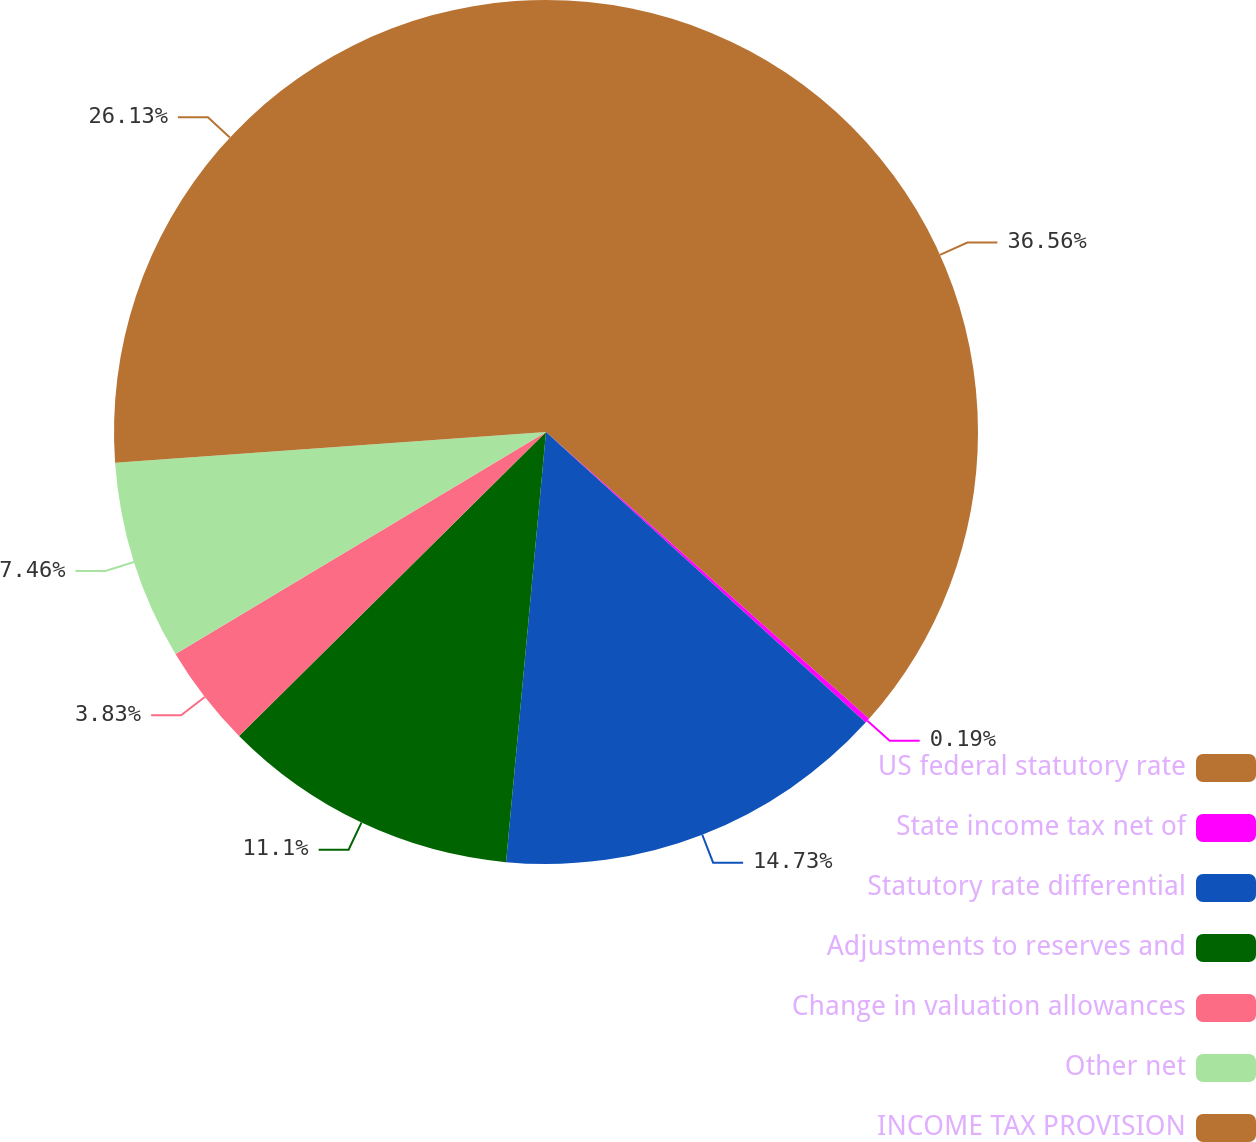<chart> <loc_0><loc_0><loc_500><loc_500><pie_chart><fcel>US federal statutory rate<fcel>State income tax net of<fcel>Statutory rate differential<fcel>Adjustments to reserves and<fcel>Change in valuation allowances<fcel>Other net<fcel>INCOME TAX PROVISION<nl><fcel>36.55%<fcel>0.19%<fcel>14.73%<fcel>11.1%<fcel>3.83%<fcel>7.46%<fcel>26.13%<nl></chart> 